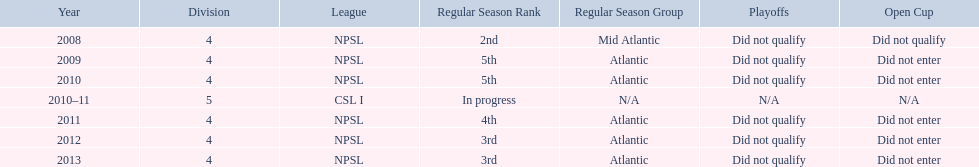Other than npsl, what league has ny mens soccer team played in? CSL I. Could you help me parse every detail presented in this table? {'header': ['Year', 'Division', 'League', 'Regular Season Rank', 'Regular Season Group', 'Playoffs', 'Open Cup'], 'rows': [['2008', '4', 'NPSL', '2nd', 'Mid Atlantic', 'Did not qualify', 'Did not qualify'], ['2009', '4', 'NPSL', '5th', 'Atlantic', 'Did not qualify', 'Did not enter'], ['2010', '4', 'NPSL', '5th', 'Atlantic', 'Did not qualify', 'Did not enter'], ['2010–11', '5', 'CSL I', 'In progress', 'N/A', 'N/A', 'N/A'], ['2011', '4', 'NPSL', '4th', 'Atlantic', 'Did not qualify', 'Did not enter'], ['2012', '4', 'NPSL', '3rd', 'Atlantic', 'Did not qualify', 'Did not enter'], ['2013', '4', 'NPSL', '3rd', 'Atlantic', 'Did not qualify', 'Did not enter']]} 